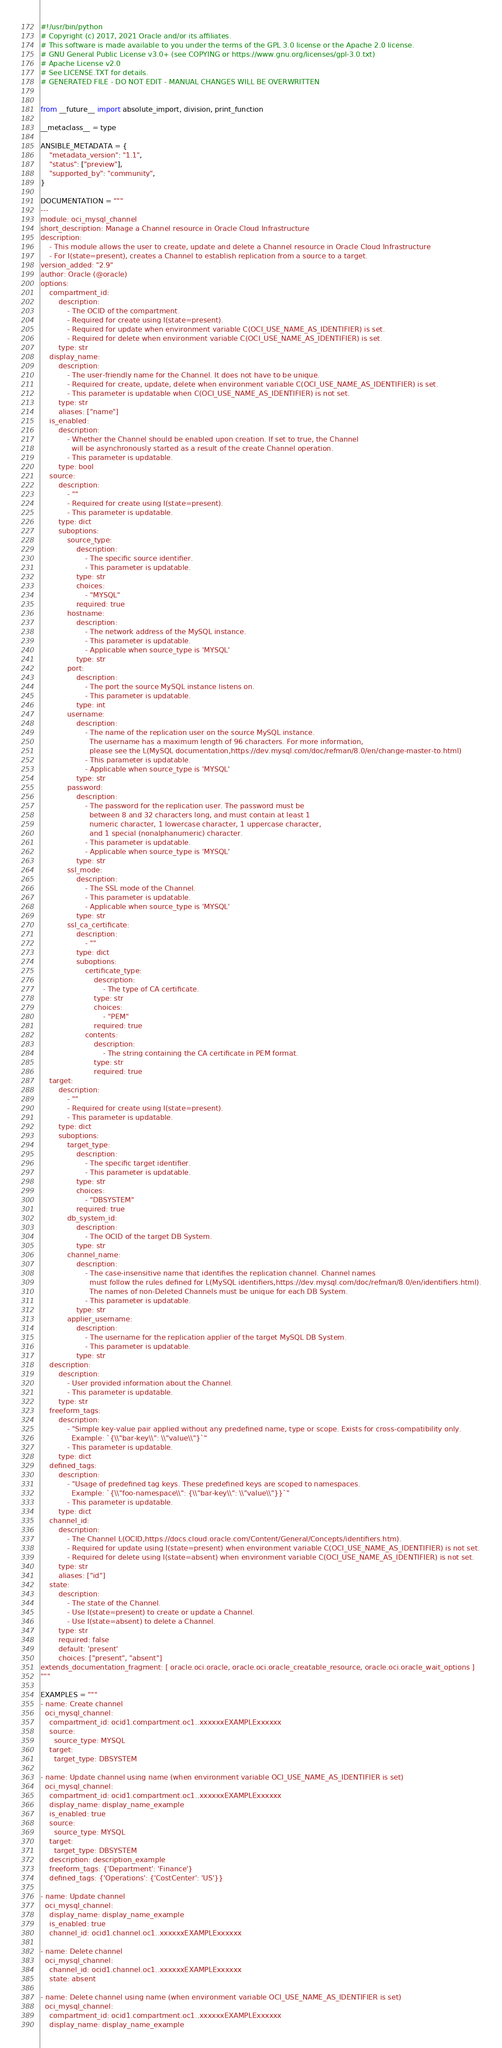Convert code to text. <code><loc_0><loc_0><loc_500><loc_500><_Python_>#!/usr/bin/python
# Copyright (c) 2017, 2021 Oracle and/or its affiliates.
# This software is made available to you under the terms of the GPL 3.0 license or the Apache 2.0 license.
# GNU General Public License v3.0+ (see COPYING or https://www.gnu.org/licenses/gpl-3.0.txt)
# Apache License v2.0
# See LICENSE.TXT for details.
# GENERATED FILE - DO NOT EDIT - MANUAL CHANGES WILL BE OVERWRITTEN


from __future__ import absolute_import, division, print_function

__metaclass__ = type

ANSIBLE_METADATA = {
    "metadata_version": "1.1",
    "status": ["preview"],
    "supported_by": "community",
}

DOCUMENTATION = """
---
module: oci_mysql_channel
short_description: Manage a Channel resource in Oracle Cloud Infrastructure
description:
    - This module allows the user to create, update and delete a Channel resource in Oracle Cloud Infrastructure
    - For I(state=present), creates a Channel to establish replication from a source to a target.
version_added: "2.9"
author: Oracle (@oracle)
options:
    compartment_id:
        description:
            - The OCID of the compartment.
            - Required for create using I(state=present).
            - Required for update when environment variable C(OCI_USE_NAME_AS_IDENTIFIER) is set.
            - Required for delete when environment variable C(OCI_USE_NAME_AS_IDENTIFIER) is set.
        type: str
    display_name:
        description:
            - The user-friendly name for the Channel. It does not have to be unique.
            - Required for create, update, delete when environment variable C(OCI_USE_NAME_AS_IDENTIFIER) is set.
            - This parameter is updatable when C(OCI_USE_NAME_AS_IDENTIFIER) is not set.
        type: str
        aliases: ["name"]
    is_enabled:
        description:
            - Whether the Channel should be enabled upon creation. If set to true, the Channel
              will be asynchronously started as a result of the create Channel operation.
            - This parameter is updatable.
        type: bool
    source:
        description:
            - ""
            - Required for create using I(state=present).
            - This parameter is updatable.
        type: dict
        suboptions:
            source_type:
                description:
                    - The specific source identifier.
                    - This parameter is updatable.
                type: str
                choices:
                    - "MYSQL"
                required: true
            hostname:
                description:
                    - The network address of the MySQL instance.
                    - This parameter is updatable.
                    - Applicable when source_type is 'MYSQL'
                type: str
            port:
                description:
                    - The port the source MySQL instance listens on.
                    - This parameter is updatable.
                type: int
            username:
                description:
                    - The name of the replication user on the source MySQL instance.
                      The username has a maximum length of 96 characters. For more information,
                      please see the L(MySQL documentation,https://dev.mysql.com/doc/refman/8.0/en/change-master-to.html)
                    - This parameter is updatable.
                    - Applicable when source_type is 'MYSQL'
                type: str
            password:
                description:
                    - The password for the replication user. The password must be
                      between 8 and 32 characters long, and must contain at least 1
                      numeric character, 1 lowercase character, 1 uppercase character,
                      and 1 special (nonalphanumeric) character.
                    - This parameter is updatable.
                    - Applicable when source_type is 'MYSQL'
                type: str
            ssl_mode:
                description:
                    - The SSL mode of the Channel.
                    - This parameter is updatable.
                    - Applicable when source_type is 'MYSQL'
                type: str
            ssl_ca_certificate:
                description:
                    - ""
                type: dict
                suboptions:
                    certificate_type:
                        description:
                            - The type of CA certificate.
                        type: str
                        choices:
                            - "PEM"
                        required: true
                    contents:
                        description:
                            - The string containing the CA certificate in PEM format.
                        type: str
                        required: true
    target:
        description:
            - ""
            - Required for create using I(state=present).
            - This parameter is updatable.
        type: dict
        suboptions:
            target_type:
                description:
                    - The specific target identifier.
                    - This parameter is updatable.
                type: str
                choices:
                    - "DBSYSTEM"
                required: true
            db_system_id:
                description:
                    - The OCID of the target DB System.
                type: str
            channel_name:
                description:
                    - The case-insensitive name that identifies the replication channel. Channel names
                      must follow the rules defined for L(MySQL identifiers,https://dev.mysql.com/doc/refman/8.0/en/identifiers.html).
                      The names of non-Deleted Channels must be unique for each DB System.
                    - This parameter is updatable.
                type: str
            applier_username:
                description:
                    - The username for the replication applier of the target MySQL DB System.
                    - This parameter is updatable.
                type: str
    description:
        description:
            - User provided information about the Channel.
            - This parameter is updatable.
        type: str
    freeform_tags:
        description:
            - "Simple key-value pair applied without any predefined name, type or scope. Exists for cross-compatibility only.
              Example: `{\\"bar-key\\": \\"value\\"}`"
            - This parameter is updatable.
        type: dict
    defined_tags:
        description:
            - "Usage of predefined tag keys. These predefined keys are scoped to namespaces.
              Example: `{\\"foo-namespace\\": {\\"bar-key\\": \\"value\\"}}`"
            - This parameter is updatable.
        type: dict
    channel_id:
        description:
            - The Channel L(OCID,https://docs.cloud.oracle.com/Content/General/Concepts/identifiers.htm).
            - Required for update using I(state=present) when environment variable C(OCI_USE_NAME_AS_IDENTIFIER) is not set.
            - Required for delete using I(state=absent) when environment variable C(OCI_USE_NAME_AS_IDENTIFIER) is not set.
        type: str
        aliases: ["id"]
    state:
        description:
            - The state of the Channel.
            - Use I(state=present) to create or update a Channel.
            - Use I(state=absent) to delete a Channel.
        type: str
        required: false
        default: 'present'
        choices: ["present", "absent"]
extends_documentation_fragment: [ oracle.oci.oracle, oracle.oci.oracle_creatable_resource, oracle.oci.oracle_wait_options ]
"""

EXAMPLES = """
- name: Create channel
  oci_mysql_channel:
    compartment_id: ocid1.compartment.oc1..xxxxxxEXAMPLExxxxxx
    source:
      source_type: MYSQL
    target:
      target_type: DBSYSTEM

- name: Update channel using name (when environment variable OCI_USE_NAME_AS_IDENTIFIER is set)
  oci_mysql_channel:
    compartment_id: ocid1.compartment.oc1..xxxxxxEXAMPLExxxxxx
    display_name: display_name_example
    is_enabled: true
    source:
      source_type: MYSQL
    target:
      target_type: DBSYSTEM
    description: description_example
    freeform_tags: {'Department': 'Finance'}
    defined_tags: {'Operations': {'CostCenter': 'US'}}

- name: Update channel
  oci_mysql_channel:
    display_name: display_name_example
    is_enabled: true
    channel_id: ocid1.channel.oc1..xxxxxxEXAMPLExxxxxx

- name: Delete channel
  oci_mysql_channel:
    channel_id: ocid1.channel.oc1..xxxxxxEXAMPLExxxxxx
    state: absent

- name: Delete channel using name (when environment variable OCI_USE_NAME_AS_IDENTIFIER is set)
  oci_mysql_channel:
    compartment_id: ocid1.compartment.oc1..xxxxxxEXAMPLExxxxxx
    display_name: display_name_example</code> 